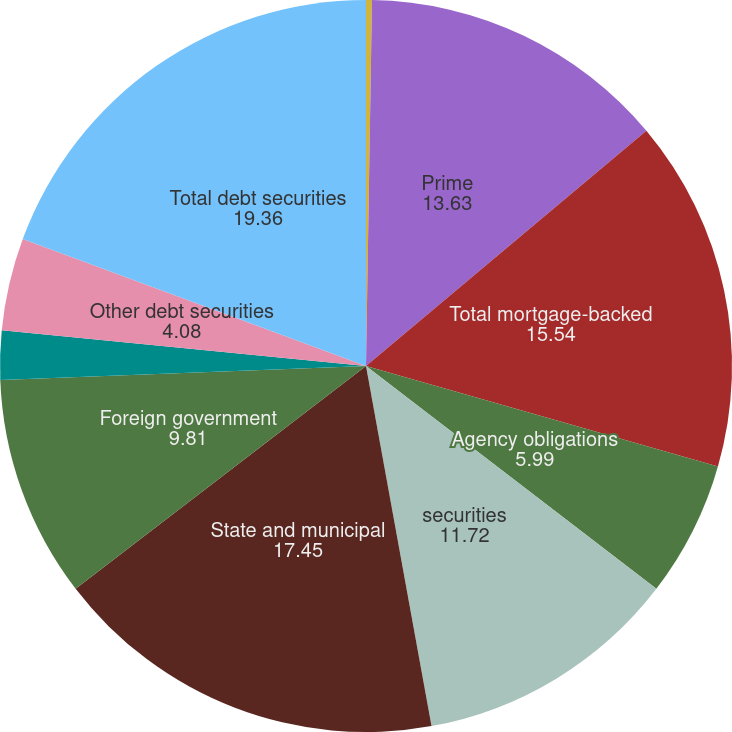<chart> <loc_0><loc_0><loc_500><loc_500><pie_chart><fcel>US government-agency<fcel>Prime<fcel>Total mortgage-backed<fcel>Agency obligations<fcel>securities<fcel>State and municipal<fcel>Foreign government<fcel>Corporate<fcel>Other debt securities<fcel>Total debt securities<nl><fcel>0.26%<fcel>13.63%<fcel>15.54%<fcel>5.99%<fcel>11.72%<fcel>17.45%<fcel>9.81%<fcel>2.17%<fcel>4.08%<fcel>19.36%<nl></chart> 